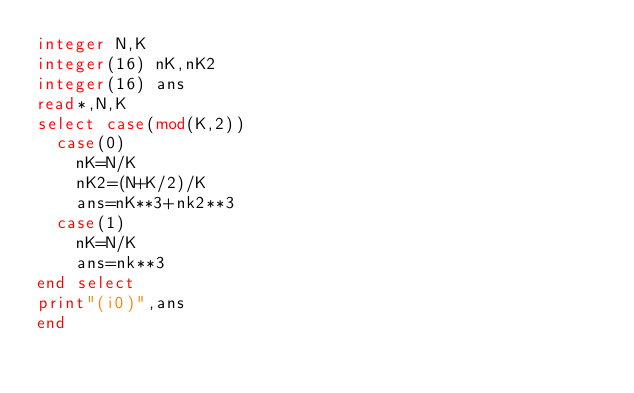Convert code to text. <code><loc_0><loc_0><loc_500><loc_500><_FORTRAN_>integer N,K
integer(16) nK,nK2
integer(16) ans
read*,N,K
select case(mod(K,2))
  case(0)
    nK=N/K
    nK2=(N+K/2)/K
    ans=nK**3+nk2**3
  case(1)
    nK=N/K
    ans=nk**3
end select
print"(i0)",ans
end</code> 